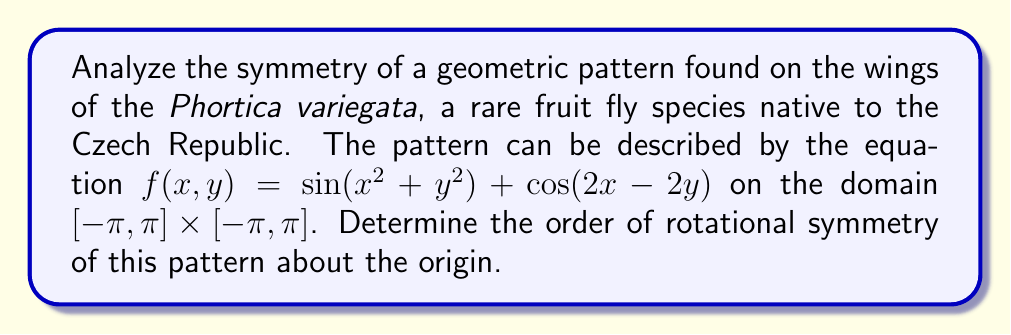Can you solve this math problem? To analyze the rotational symmetry of the given pattern, we need to follow these steps:

1) The function $f(x,y) = \sin(x^2 + y^2) + \cos(2x - 2y)$ describes the pattern.

2) For rotational symmetry of order n, the function should remain unchanged when rotated by $\frac{2\pi}{n}$ radians about the origin.

3) Mathematically, this means $f(x,y) = f(x\cos\theta - y\sin\theta, x\sin\theta + y\cos\theta)$ where $\theta = \frac{2\pi}{n}$.

4) Let's apply this transformation:

   $f(x\cos\theta - y\sin\theta, x\sin\theta + y\cos\theta)$
   $= \sin((x\cos\theta - y\sin\theta)^2 + (x\sin\theta + y\cos\theta)^2)$
   $+ \cos(2(x\cos\theta - y\sin\theta) - 2(x\sin\theta + y\cos\theta))$

5) Simplify the first term:
   $(x\cos\theta - y\sin\theta)^2 + (x\sin\theta + y\cos\theta)^2$
   $= x^2\cos^2\theta + y^2\sin^2\theta - 2xy\cos\theta\sin\theta + x^2\sin^2\theta + y^2\cos^2\theta + 2xy\sin\theta\cos\theta$
   $= x^2(\cos^2\theta + \sin^2\theta) + y^2(\sin^2\theta + \cos^2\theta)$
   $= x^2 + y^2$

6) Simplify the second term:
   $2(x\cos\theta - y\sin\theta) - 2(x\sin\theta + y\cos\theta)$
   $= 2x\cos\theta - 2y\sin\theta - 2x\sin\theta - 2y\cos\theta$
   $= 2x(\cos\theta - \sin\theta) - 2y(\sin\theta + \cos\theta)$

7) For this to equal the original function, we need:
   $\cos\theta - \sin\theta = 1$ and $\sin\theta + \cos\theta = 1$

8) Solving these equations simultaneously:
   $\cos\theta = 1$ and $\sin\theta = 0$

9) This occurs when $\theta = 0, 2\pi, 4\pi, ...$

10) The smallest positive value that satisfies this is $\theta = 2\pi$, which corresponds to a full rotation.

Therefore, the pattern has rotational symmetry of order 1, meaning it has no rotational symmetry other than a full 360° rotation.
Answer: 1 